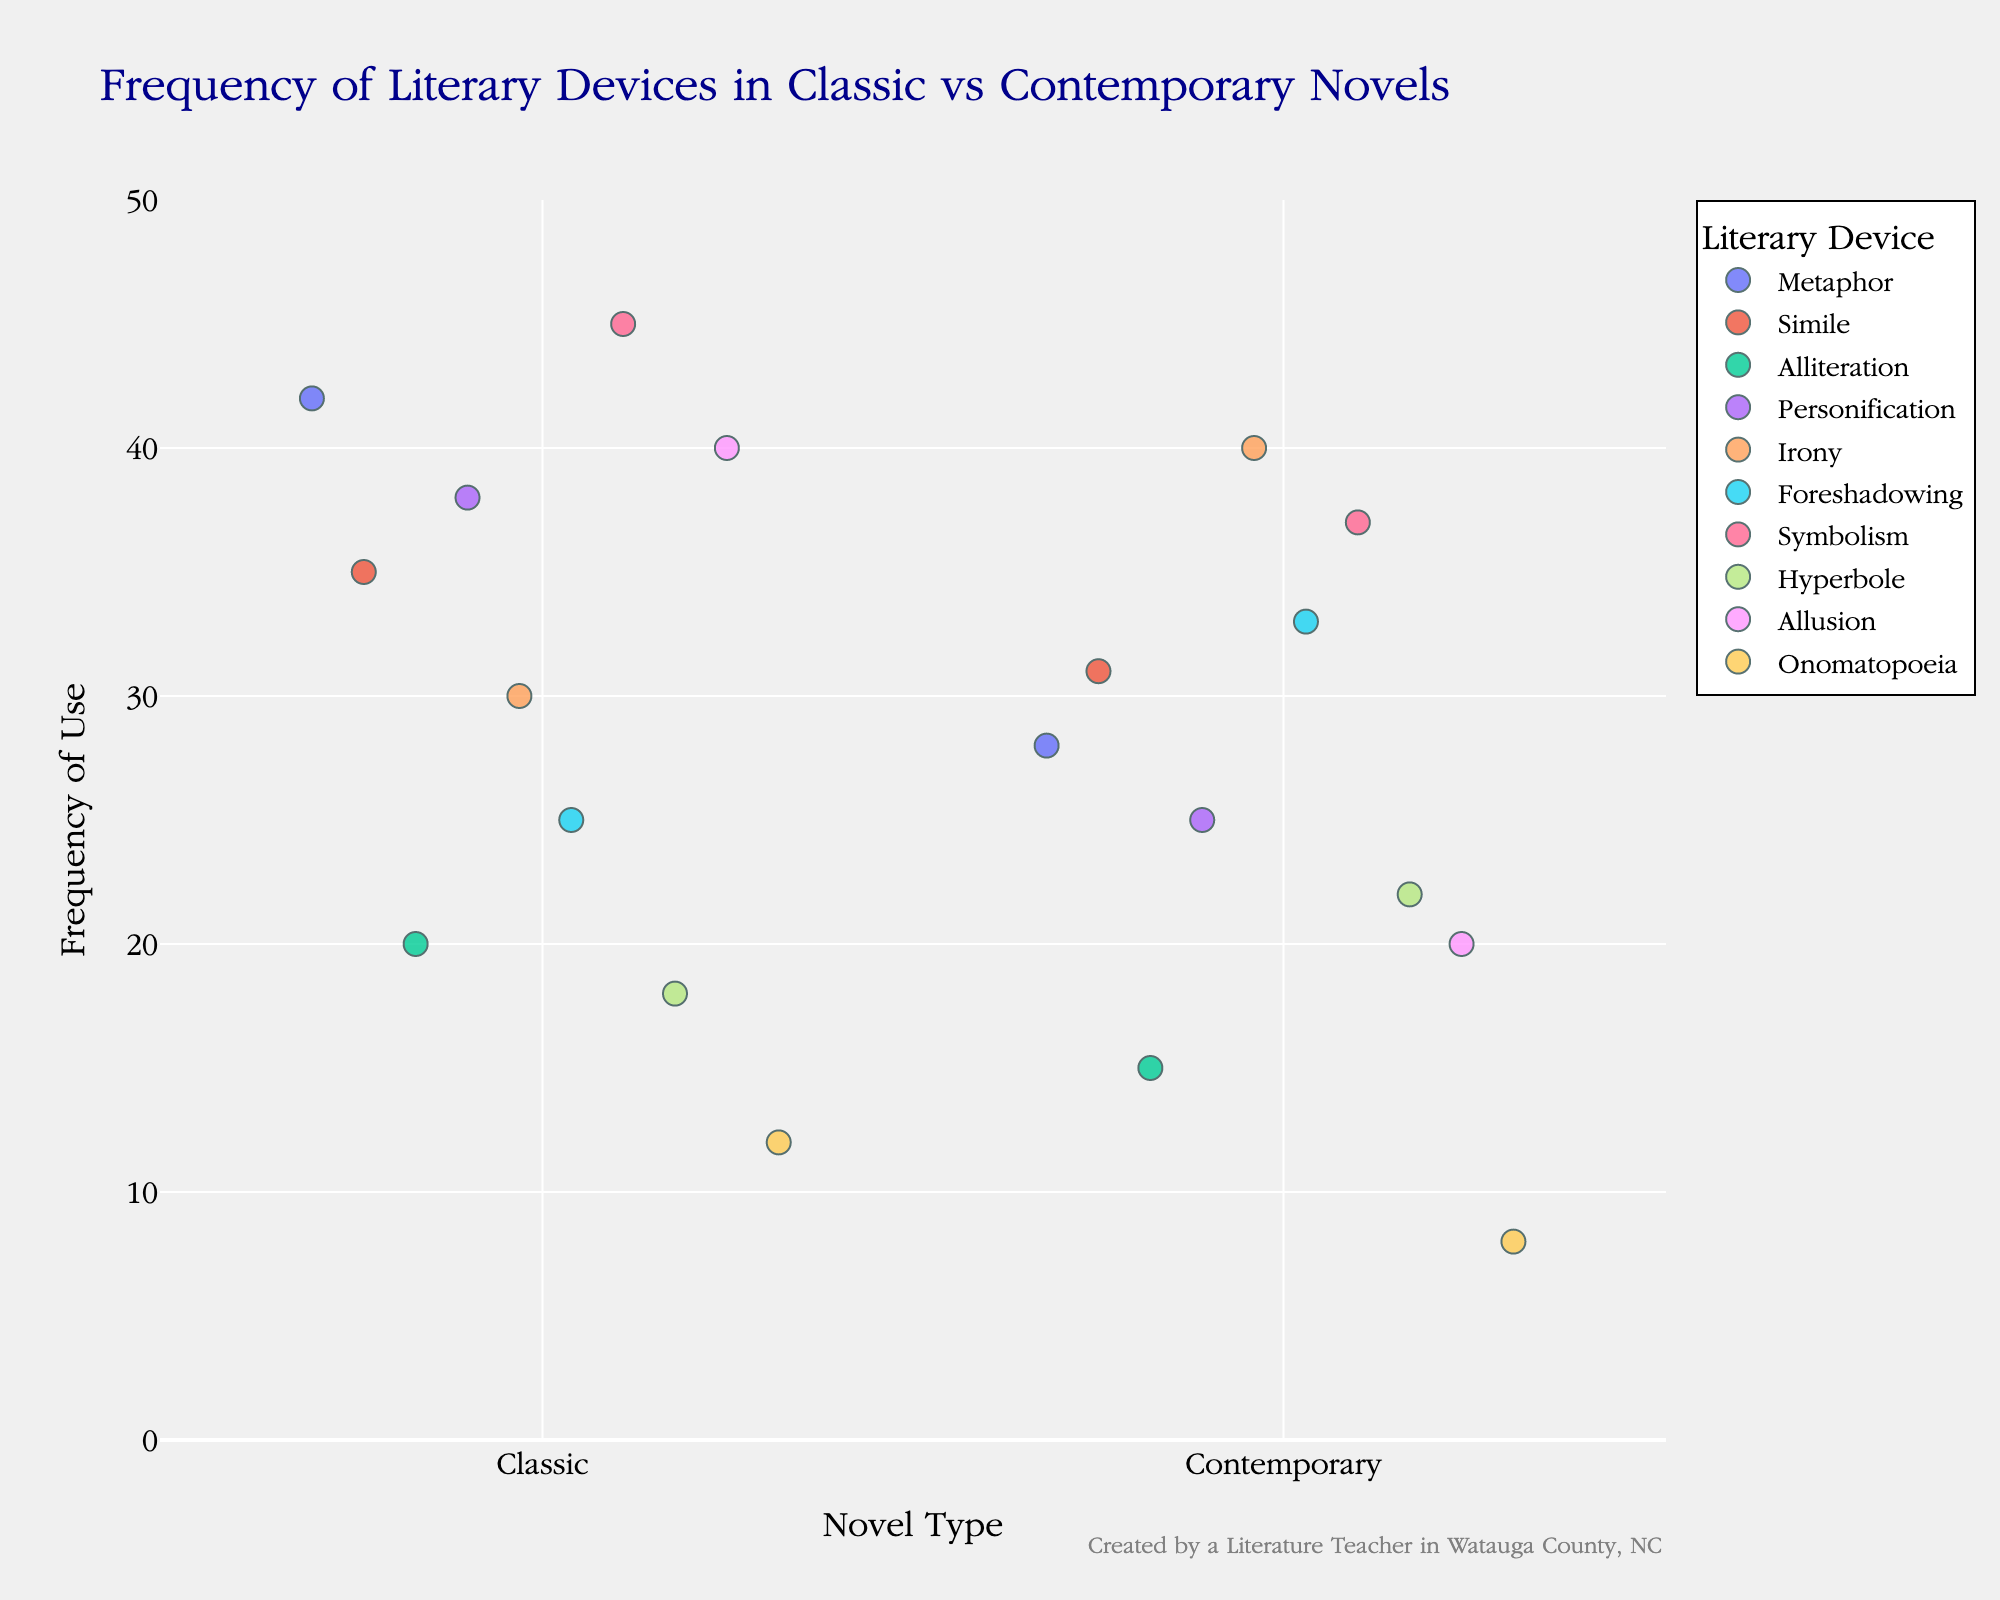What are the novel types mentioned in the figure? The figure compares two types of novels: Classic and Contemporary, as indicated by the x-axis labels.
Answer: Classic and Contemporary Which literary device shows the highest frequency in classic novels? Observing the y-axis values for classic novels, Symbolism has the highest frequency with a value of 45.
Answer: Symbolism How many literary devices have a higher frequency in classic novels compared to contemporary novels? By comparing each literary device between the two novel types, 6 devices (Metaphor, Simile, Personification, Symbolism, Allusion, Onomatopoeia) have higher frequency in classic novels.
Answer: 6 Which literary device in contemporary novels has the highest frequency? Observing the y-axis values for contemporary novels, Irony has the highest frequency with a value of 40.
Answer: Irony What is the frequency difference of Allusion between the two novel types? For Allusion, the frequency is 40 in classic novels and 20 in contemporary novels. The difference is 40 - 20 = 20.
Answer: 20 Which literary device in contemporary novels shows a greater frequency than in classic novels? Comparing the frequencies, two devices (Irony and Foreshadowing) have a greater frequency in contemporary novels than in classic novels.
Answer: Irony and Foreshadowing Calculate the average frequency of literary devices in contemporary novels. Summing up the frequencies for contemporary novels: 28 + 31 + 15 + 25 + 40 + 33 + 37 + 22 + 20 + 8 = 259. There are 10 devices, thus the average frequency is 259/10 = 25.9.
Answer: 25.9 Considering Metaphor and Simile, which novel type uses them more frequently? For Metaphor, classic is 42 and contemporary is 28. For Simile, classic is 35 and contemporary is 31. In both cases, classic novels use them more frequently.
Answer: Classic By how much does the frequency of Alliteration differ between classic and contemporary novels? The frequency for Alliteration in classic novels is 20 and in contemporary novels is 15. The difference is 20 - 15 = 5.
Answer: 5 Which literary device shows the smallest difference in frequency between the two novel types? Comparing the differences, Hyperbole has the smallest difference: 18 (classic) - 22 (contemporary) = -4.
Answer: Hyperbole 